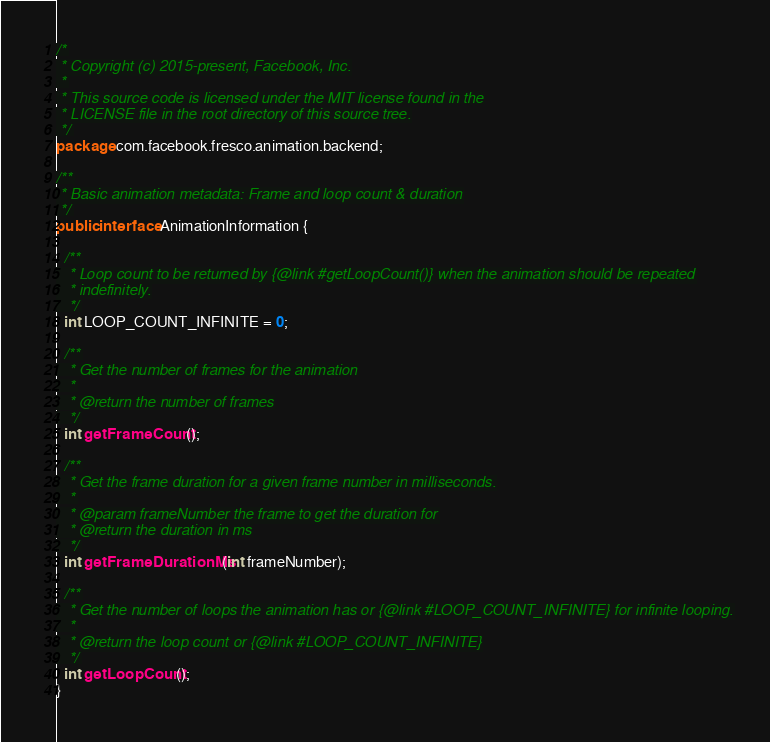Convert code to text. <code><loc_0><loc_0><loc_500><loc_500><_Java_>/*
 * Copyright (c) 2015-present, Facebook, Inc.
 *
 * This source code is licensed under the MIT license found in the
 * LICENSE file in the root directory of this source tree.
 */
package com.facebook.fresco.animation.backend;

/**
 * Basic animation metadata: Frame and loop count & duration
 */
public interface AnimationInformation {

  /**
   * Loop count to be returned by {@link #getLoopCount()} when the animation should be repeated
   * indefinitely.
   */
  int LOOP_COUNT_INFINITE = 0;

  /**
   * Get the number of frames for the animation
   *
   * @return the number of frames
   */
  int getFrameCount();

  /**
   * Get the frame duration for a given frame number in milliseconds.
   *
   * @param frameNumber the frame to get the duration for
   * @return the duration in ms
   */
  int getFrameDurationMs(int frameNumber);

  /**
   * Get the number of loops the animation has or {@link #LOOP_COUNT_INFINITE} for infinite looping.
   *
   * @return the loop count or {@link #LOOP_COUNT_INFINITE}
   */
  int getLoopCount();
}
</code> 